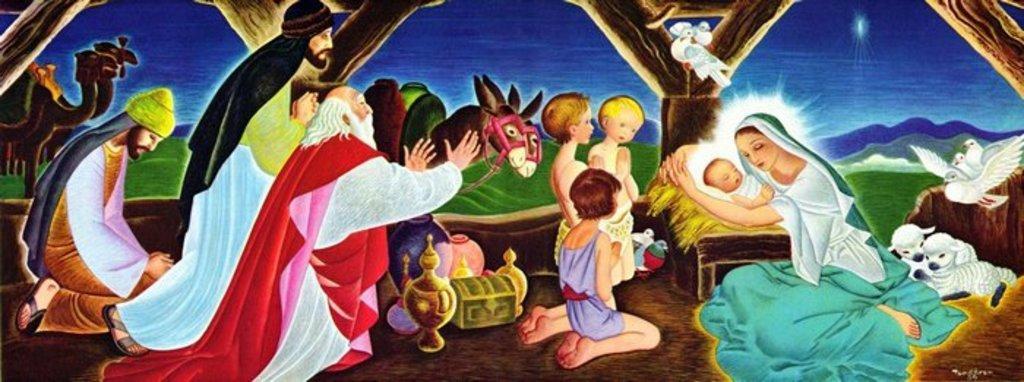Please provide a concise description of this image. In this picture I can see an depiction image where I can see number of people, few birds, few things and in the background I can see the grass and the sky. I can also see 2 sheep. 